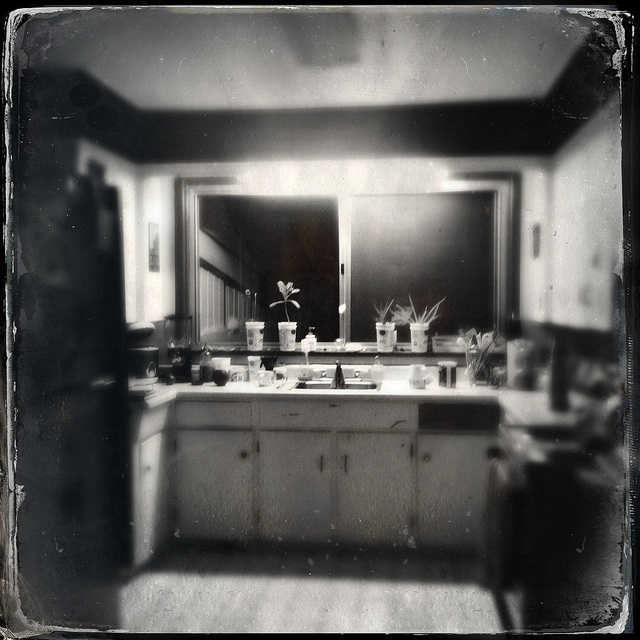Describe the objects in this image and their specific colors. I can see refrigerator in black, gray, and darkgray tones, bottle in black and gray tones, potted plant in black, darkgray, gray, and lightgray tones, potted plant in black, darkgray, gray, and lightgray tones, and potted plant in black, darkgray, gray, and lightgray tones in this image. 